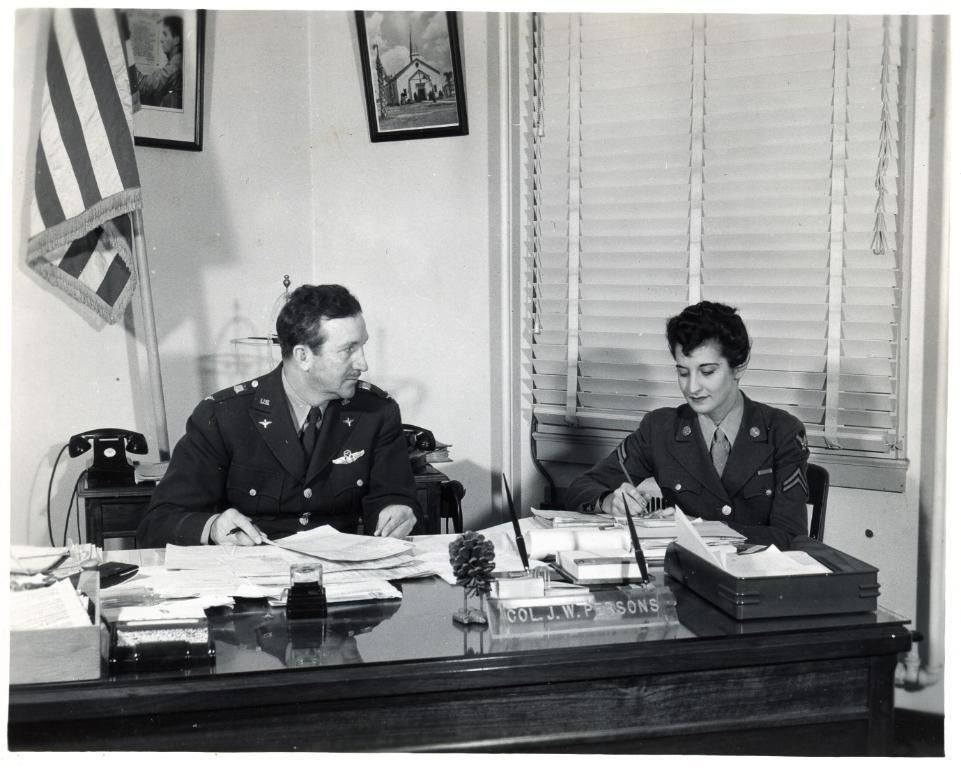Can you describe this image briefly? It is a black and white image, there is a table in the foreground and on the table there are papers and other objects, behind the table there are two people sitting on the chair and behind the man there is a telephone, a flag and a wall and there are two frames attached to the wall and on the right side there is a woman, behind her there is a blind. 